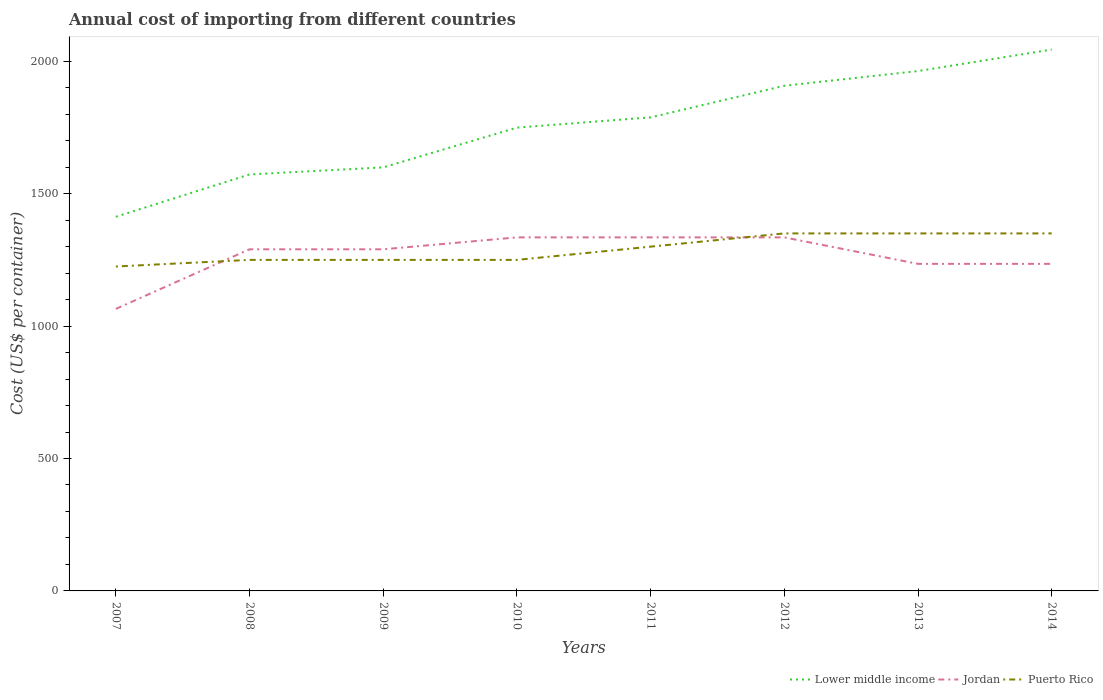How many different coloured lines are there?
Your answer should be compact. 3. Is the number of lines equal to the number of legend labels?
Your answer should be very brief. Yes. Across all years, what is the maximum total annual cost of importing in Jordan?
Offer a very short reply. 1065. In which year was the total annual cost of importing in Lower middle income maximum?
Your answer should be compact. 2007. What is the total total annual cost of importing in Jordan in the graph?
Make the answer very short. -170. What is the difference between the highest and the second highest total annual cost of importing in Jordan?
Provide a succinct answer. 270. Is the total annual cost of importing in Puerto Rico strictly greater than the total annual cost of importing in Jordan over the years?
Keep it short and to the point. No. How many lines are there?
Provide a short and direct response. 3. How many years are there in the graph?
Make the answer very short. 8. What is the difference between two consecutive major ticks on the Y-axis?
Give a very brief answer. 500. Are the values on the major ticks of Y-axis written in scientific E-notation?
Offer a very short reply. No. Does the graph contain any zero values?
Offer a very short reply. No. Does the graph contain grids?
Make the answer very short. No. Where does the legend appear in the graph?
Offer a terse response. Bottom right. What is the title of the graph?
Keep it short and to the point. Annual cost of importing from different countries. Does "Belize" appear as one of the legend labels in the graph?
Offer a terse response. No. What is the label or title of the Y-axis?
Provide a succinct answer. Cost (US$ per container). What is the Cost (US$ per container) in Lower middle income in 2007?
Offer a terse response. 1412.82. What is the Cost (US$ per container) in Jordan in 2007?
Give a very brief answer. 1065. What is the Cost (US$ per container) of Puerto Rico in 2007?
Keep it short and to the point. 1225. What is the Cost (US$ per container) in Lower middle income in 2008?
Give a very brief answer. 1572.65. What is the Cost (US$ per container) of Jordan in 2008?
Offer a terse response. 1290. What is the Cost (US$ per container) of Puerto Rico in 2008?
Your response must be concise. 1250. What is the Cost (US$ per container) in Lower middle income in 2009?
Ensure brevity in your answer.  1599.32. What is the Cost (US$ per container) of Jordan in 2009?
Ensure brevity in your answer.  1290. What is the Cost (US$ per container) in Puerto Rico in 2009?
Offer a very short reply. 1250. What is the Cost (US$ per container) of Lower middle income in 2010?
Offer a very short reply. 1749.42. What is the Cost (US$ per container) in Jordan in 2010?
Your answer should be very brief. 1335. What is the Cost (US$ per container) of Puerto Rico in 2010?
Keep it short and to the point. 1250. What is the Cost (US$ per container) of Lower middle income in 2011?
Your response must be concise. 1788.26. What is the Cost (US$ per container) of Jordan in 2011?
Offer a very short reply. 1335. What is the Cost (US$ per container) of Puerto Rico in 2011?
Provide a succinct answer. 1300. What is the Cost (US$ per container) in Lower middle income in 2012?
Your answer should be very brief. 1907.47. What is the Cost (US$ per container) of Jordan in 2012?
Provide a succinct answer. 1335. What is the Cost (US$ per container) of Puerto Rico in 2012?
Make the answer very short. 1350. What is the Cost (US$ per container) of Lower middle income in 2013?
Your response must be concise. 1963.03. What is the Cost (US$ per container) of Jordan in 2013?
Your answer should be very brief. 1235. What is the Cost (US$ per container) in Puerto Rico in 2013?
Offer a terse response. 1350. What is the Cost (US$ per container) of Lower middle income in 2014?
Provide a short and direct response. 2044.26. What is the Cost (US$ per container) of Jordan in 2014?
Ensure brevity in your answer.  1235. What is the Cost (US$ per container) in Puerto Rico in 2014?
Keep it short and to the point. 1350. Across all years, what is the maximum Cost (US$ per container) of Lower middle income?
Offer a terse response. 2044.26. Across all years, what is the maximum Cost (US$ per container) in Jordan?
Make the answer very short. 1335. Across all years, what is the maximum Cost (US$ per container) in Puerto Rico?
Keep it short and to the point. 1350. Across all years, what is the minimum Cost (US$ per container) of Lower middle income?
Give a very brief answer. 1412.82. Across all years, what is the minimum Cost (US$ per container) in Jordan?
Offer a very short reply. 1065. Across all years, what is the minimum Cost (US$ per container) of Puerto Rico?
Offer a very short reply. 1225. What is the total Cost (US$ per container) in Lower middle income in the graph?
Make the answer very short. 1.40e+04. What is the total Cost (US$ per container) of Jordan in the graph?
Offer a terse response. 1.01e+04. What is the total Cost (US$ per container) of Puerto Rico in the graph?
Provide a succinct answer. 1.03e+04. What is the difference between the Cost (US$ per container) in Lower middle income in 2007 and that in 2008?
Provide a succinct answer. -159.84. What is the difference between the Cost (US$ per container) of Jordan in 2007 and that in 2008?
Offer a very short reply. -225. What is the difference between the Cost (US$ per container) of Puerto Rico in 2007 and that in 2008?
Your answer should be very brief. -25. What is the difference between the Cost (US$ per container) of Lower middle income in 2007 and that in 2009?
Ensure brevity in your answer.  -186.5. What is the difference between the Cost (US$ per container) of Jordan in 2007 and that in 2009?
Provide a short and direct response. -225. What is the difference between the Cost (US$ per container) of Lower middle income in 2007 and that in 2010?
Make the answer very short. -336.6. What is the difference between the Cost (US$ per container) of Jordan in 2007 and that in 2010?
Offer a very short reply. -270. What is the difference between the Cost (US$ per container) of Puerto Rico in 2007 and that in 2010?
Your answer should be very brief. -25. What is the difference between the Cost (US$ per container) of Lower middle income in 2007 and that in 2011?
Provide a succinct answer. -375.44. What is the difference between the Cost (US$ per container) in Jordan in 2007 and that in 2011?
Keep it short and to the point. -270. What is the difference between the Cost (US$ per container) of Puerto Rico in 2007 and that in 2011?
Your response must be concise. -75. What is the difference between the Cost (US$ per container) of Lower middle income in 2007 and that in 2012?
Your answer should be very brief. -494.65. What is the difference between the Cost (US$ per container) in Jordan in 2007 and that in 2012?
Give a very brief answer. -270. What is the difference between the Cost (US$ per container) in Puerto Rico in 2007 and that in 2012?
Keep it short and to the point. -125. What is the difference between the Cost (US$ per container) in Lower middle income in 2007 and that in 2013?
Provide a succinct answer. -550.21. What is the difference between the Cost (US$ per container) of Jordan in 2007 and that in 2013?
Keep it short and to the point. -170. What is the difference between the Cost (US$ per container) in Puerto Rico in 2007 and that in 2013?
Provide a succinct answer. -125. What is the difference between the Cost (US$ per container) in Lower middle income in 2007 and that in 2014?
Provide a short and direct response. -631.44. What is the difference between the Cost (US$ per container) in Jordan in 2007 and that in 2014?
Ensure brevity in your answer.  -170. What is the difference between the Cost (US$ per container) in Puerto Rico in 2007 and that in 2014?
Make the answer very short. -125. What is the difference between the Cost (US$ per container) in Lower middle income in 2008 and that in 2009?
Ensure brevity in your answer.  -26.67. What is the difference between the Cost (US$ per container) of Jordan in 2008 and that in 2009?
Offer a very short reply. 0. What is the difference between the Cost (US$ per container) of Puerto Rico in 2008 and that in 2009?
Offer a very short reply. 0. What is the difference between the Cost (US$ per container) of Lower middle income in 2008 and that in 2010?
Provide a short and direct response. -176.77. What is the difference between the Cost (US$ per container) of Jordan in 2008 and that in 2010?
Give a very brief answer. -45. What is the difference between the Cost (US$ per container) in Puerto Rico in 2008 and that in 2010?
Keep it short and to the point. 0. What is the difference between the Cost (US$ per container) in Lower middle income in 2008 and that in 2011?
Provide a succinct answer. -215.61. What is the difference between the Cost (US$ per container) in Jordan in 2008 and that in 2011?
Offer a very short reply. -45. What is the difference between the Cost (US$ per container) in Lower middle income in 2008 and that in 2012?
Your answer should be compact. -334.82. What is the difference between the Cost (US$ per container) in Jordan in 2008 and that in 2012?
Make the answer very short. -45. What is the difference between the Cost (US$ per container) of Puerto Rico in 2008 and that in 2012?
Your answer should be compact. -100. What is the difference between the Cost (US$ per container) of Lower middle income in 2008 and that in 2013?
Your answer should be very brief. -390.37. What is the difference between the Cost (US$ per container) of Puerto Rico in 2008 and that in 2013?
Give a very brief answer. -100. What is the difference between the Cost (US$ per container) of Lower middle income in 2008 and that in 2014?
Provide a short and direct response. -471.61. What is the difference between the Cost (US$ per container) of Jordan in 2008 and that in 2014?
Provide a short and direct response. 55. What is the difference between the Cost (US$ per container) of Puerto Rico in 2008 and that in 2014?
Ensure brevity in your answer.  -100. What is the difference between the Cost (US$ per container) in Lower middle income in 2009 and that in 2010?
Ensure brevity in your answer.  -150.1. What is the difference between the Cost (US$ per container) of Jordan in 2009 and that in 2010?
Your response must be concise. -45. What is the difference between the Cost (US$ per container) in Puerto Rico in 2009 and that in 2010?
Ensure brevity in your answer.  0. What is the difference between the Cost (US$ per container) of Lower middle income in 2009 and that in 2011?
Provide a short and direct response. -188.94. What is the difference between the Cost (US$ per container) in Jordan in 2009 and that in 2011?
Make the answer very short. -45. What is the difference between the Cost (US$ per container) of Puerto Rico in 2009 and that in 2011?
Provide a short and direct response. -50. What is the difference between the Cost (US$ per container) of Lower middle income in 2009 and that in 2012?
Provide a short and direct response. -308.15. What is the difference between the Cost (US$ per container) in Jordan in 2009 and that in 2012?
Provide a succinct answer. -45. What is the difference between the Cost (US$ per container) in Puerto Rico in 2009 and that in 2012?
Make the answer very short. -100. What is the difference between the Cost (US$ per container) of Lower middle income in 2009 and that in 2013?
Provide a short and direct response. -363.71. What is the difference between the Cost (US$ per container) in Puerto Rico in 2009 and that in 2013?
Keep it short and to the point. -100. What is the difference between the Cost (US$ per container) in Lower middle income in 2009 and that in 2014?
Your answer should be compact. -444.94. What is the difference between the Cost (US$ per container) of Puerto Rico in 2009 and that in 2014?
Your answer should be very brief. -100. What is the difference between the Cost (US$ per container) in Lower middle income in 2010 and that in 2011?
Offer a very short reply. -38.84. What is the difference between the Cost (US$ per container) in Puerto Rico in 2010 and that in 2011?
Your answer should be very brief. -50. What is the difference between the Cost (US$ per container) in Lower middle income in 2010 and that in 2012?
Provide a succinct answer. -158.05. What is the difference between the Cost (US$ per container) of Jordan in 2010 and that in 2012?
Your answer should be compact. 0. What is the difference between the Cost (US$ per container) in Puerto Rico in 2010 and that in 2012?
Keep it short and to the point. -100. What is the difference between the Cost (US$ per container) in Lower middle income in 2010 and that in 2013?
Your response must be concise. -213.61. What is the difference between the Cost (US$ per container) of Jordan in 2010 and that in 2013?
Give a very brief answer. 100. What is the difference between the Cost (US$ per container) in Puerto Rico in 2010 and that in 2013?
Offer a terse response. -100. What is the difference between the Cost (US$ per container) in Lower middle income in 2010 and that in 2014?
Your response must be concise. -294.84. What is the difference between the Cost (US$ per container) of Jordan in 2010 and that in 2014?
Offer a terse response. 100. What is the difference between the Cost (US$ per container) in Puerto Rico in 2010 and that in 2014?
Your answer should be compact. -100. What is the difference between the Cost (US$ per container) of Lower middle income in 2011 and that in 2012?
Keep it short and to the point. -119.21. What is the difference between the Cost (US$ per container) in Lower middle income in 2011 and that in 2013?
Your answer should be very brief. -174.77. What is the difference between the Cost (US$ per container) of Puerto Rico in 2011 and that in 2013?
Keep it short and to the point. -50. What is the difference between the Cost (US$ per container) in Lower middle income in 2011 and that in 2014?
Your answer should be compact. -256. What is the difference between the Cost (US$ per container) in Jordan in 2011 and that in 2014?
Keep it short and to the point. 100. What is the difference between the Cost (US$ per container) of Puerto Rico in 2011 and that in 2014?
Your response must be concise. -50. What is the difference between the Cost (US$ per container) in Lower middle income in 2012 and that in 2013?
Your answer should be compact. -55.55. What is the difference between the Cost (US$ per container) in Puerto Rico in 2012 and that in 2013?
Keep it short and to the point. 0. What is the difference between the Cost (US$ per container) in Lower middle income in 2012 and that in 2014?
Give a very brief answer. -136.79. What is the difference between the Cost (US$ per container) of Lower middle income in 2013 and that in 2014?
Offer a very short reply. -81.24. What is the difference between the Cost (US$ per container) in Puerto Rico in 2013 and that in 2014?
Your answer should be compact. 0. What is the difference between the Cost (US$ per container) of Lower middle income in 2007 and the Cost (US$ per container) of Jordan in 2008?
Your answer should be compact. 122.82. What is the difference between the Cost (US$ per container) in Lower middle income in 2007 and the Cost (US$ per container) in Puerto Rico in 2008?
Keep it short and to the point. 162.82. What is the difference between the Cost (US$ per container) of Jordan in 2007 and the Cost (US$ per container) of Puerto Rico in 2008?
Provide a succinct answer. -185. What is the difference between the Cost (US$ per container) of Lower middle income in 2007 and the Cost (US$ per container) of Jordan in 2009?
Your answer should be compact. 122.82. What is the difference between the Cost (US$ per container) in Lower middle income in 2007 and the Cost (US$ per container) in Puerto Rico in 2009?
Your response must be concise. 162.82. What is the difference between the Cost (US$ per container) in Jordan in 2007 and the Cost (US$ per container) in Puerto Rico in 2009?
Provide a succinct answer. -185. What is the difference between the Cost (US$ per container) in Lower middle income in 2007 and the Cost (US$ per container) in Jordan in 2010?
Make the answer very short. 77.82. What is the difference between the Cost (US$ per container) of Lower middle income in 2007 and the Cost (US$ per container) of Puerto Rico in 2010?
Provide a short and direct response. 162.82. What is the difference between the Cost (US$ per container) of Jordan in 2007 and the Cost (US$ per container) of Puerto Rico in 2010?
Your response must be concise. -185. What is the difference between the Cost (US$ per container) of Lower middle income in 2007 and the Cost (US$ per container) of Jordan in 2011?
Make the answer very short. 77.82. What is the difference between the Cost (US$ per container) of Lower middle income in 2007 and the Cost (US$ per container) of Puerto Rico in 2011?
Ensure brevity in your answer.  112.82. What is the difference between the Cost (US$ per container) of Jordan in 2007 and the Cost (US$ per container) of Puerto Rico in 2011?
Offer a terse response. -235. What is the difference between the Cost (US$ per container) in Lower middle income in 2007 and the Cost (US$ per container) in Jordan in 2012?
Offer a very short reply. 77.82. What is the difference between the Cost (US$ per container) in Lower middle income in 2007 and the Cost (US$ per container) in Puerto Rico in 2012?
Make the answer very short. 62.82. What is the difference between the Cost (US$ per container) of Jordan in 2007 and the Cost (US$ per container) of Puerto Rico in 2012?
Your response must be concise. -285. What is the difference between the Cost (US$ per container) of Lower middle income in 2007 and the Cost (US$ per container) of Jordan in 2013?
Offer a terse response. 177.82. What is the difference between the Cost (US$ per container) of Lower middle income in 2007 and the Cost (US$ per container) of Puerto Rico in 2013?
Offer a terse response. 62.82. What is the difference between the Cost (US$ per container) of Jordan in 2007 and the Cost (US$ per container) of Puerto Rico in 2013?
Offer a very short reply. -285. What is the difference between the Cost (US$ per container) in Lower middle income in 2007 and the Cost (US$ per container) in Jordan in 2014?
Offer a terse response. 177.82. What is the difference between the Cost (US$ per container) in Lower middle income in 2007 and the Cost (US$ per container) in Puerto Rico in 2014?
Provide a short and direct response. 62.82. What is the difference between the Cost (US$ per container) in Jordan in 2007 and the Cost (US$ per container) in Puerto Rico in 2014?
Provide a short and direct response. -285. What is the difference between the Cost (US$ per container) in Lower middle income in 2008 and the Cost (US$ per container) in Jordan in 2009?
Provide a short and direct response. 282.65. What is the difference between the Cost (US$ per container) in Lower middle income in 2008 and the Cost (US$ per container) in Puerto Rico in 2009?
Your answer should be very brief. 322.65. What is the difference between the Cost (US$ per container) in Jordan in 2008 and the Cost (US$ per container) in Puerto Rico in 2009?
Keep it short and to the point. 40. What is the difference between the Cost (US$ per container) of Lower middle income in 2008 and the Cost (US$ per container) of Jordan in 2010?
Provide a succinct answer. 237.65. What is the difference between the Cost (US$ per container) in Lower middle income in 2008 and the Cost (US$ per container) in Puerto Rico in 2010?
Provide a short and direct response. 322.65. What is the difference between the Cost (US$ per container) in Lower middle income in 2008 and the Cost (US$ per container) in Jordan in 2011?
Give a very brief answer. 237.65. What is the difference between the Cost (US$ per container) in Lower middle income in 2008 and the Cost (US$ per container) in Puerto Rico in 2011?
Keep it short and to the point. 272.65. What is the difference between the Cost (US$ per container) of Lower middle income in 2008 and the Cost (US$ per container) of Jordan in 2012?
Your response must be concise. 237.65. What is the difference between the Cost (US$ per container) of Lower middle income in 2008 and the Cost (US$ per container) of Puerto Rico in 2012?
Give a very brief answer. 222.65. What is the difference between the Cost (US$ per container) in Jordan in 2008 and the Cost (US$ per container) in Puerto Rico in 2012?
Offer a terse response. -60. What is the difference between the Cost (US$ per container) of Lower middle income in 2008 and the Cost (US$ per container) of Jordan in 2013?
Offer a terse response. 337.65. What is the difference between the Cost (US$ per container) in Lower middle income in 2008 and the Cost (US$ per container) in Puerto Rico in 2013?
Your answer should be compact. 222.65. What is the difference between the Cost (US$ per container) of Jordan in 2008 and the Cost (US$ per container) of Puerto Rico in 2013?
Provide a short and direct response. -60. What is the difference between the Cost (US$ per container) of Lower middle income in 2008 and the Cost (US$ per container) of Jordan in 2014?
Your answer should be very brief. 337.65. What is the difference between the Cost (US$ per container) of Lower middle income in 2008 and the Cost (US$ per container) of Puerto Rico in 2014?
Make the answer very short. 222.65. What is the difference between the Cost (US$ per container) in Jordan in 2008 and the Cost (US$ per container) in Puerto Rico in 2014?
Your answer should be compact. -60. What is the difference between the Cost (US$ per container) of Lower middle income in 2009 and the Cost (US$ per container) of Jordan in 2010?
Provide a short and direct response. 264.32. What is the difference between the Cost (US$ per container) of Lower middle income in 2009 and the Cost (US$ per container) of Puerto Rico in 2010?
Your answer should be compact. 349.32. What is the difference between the Cost (US$ per container) in Jordan in 2009 and the Cost (US$ per container) in Puerto Rico in 2010?
Offer a terse response. 40. What is the difference between the Cost (US$ per container) of Lower middle income in 2009 and the Cost (US$ per container) of Jordan in 2011?
Offer a very short reply. 264.32. What is the difference between the Cost (US$ per container) in Lower middle income in 2009 and the Cost (US$ per container) in Puerto Rico in 2011?
Your answer should be very brief. 299.32. What is the difference between the Cost (US$ per container) of Jordan in 2009 and the Cost (US$ per container) of Puerto Rico in 2011?
Ensure brevity in your answer.  -10. What is the difference between the Cost (US$ per container) of Lower middle income in 2009 and the Cost (US$ per container) of Jordan in 2012?
Make the answer very short. 264.32. What is the difference between the Cost (US$ per container) in Lower middle income in 2009 and the Cost (US$ per container) in Puerto Rico in 2012?
Your response must be concise. 249.32. What is the difference between the Cost (US$ per container) of Jordan in 2009 and the Cost (US$ per container) of Puerto Rico in 2012?
Offer a very short reply. -60. What is the difference between the Cost (US$ per container) in Lower middle income in 2009 and the Cost (US$ per container) in Jordan in 2013?
Give a very brief answer. 364.32. What is the difference between the Cost (US$ per container) in Lower middle income in 2009 and the Cost (US$ per container) in Puerto Rico in 2013?
Offer a terse response. 249.32. What is the difference between the Cost (US$ per container) of Jordan in 2009 and the Cost (US$ per container) of Puerto Rico in 2013?
Make the answer very short. -60. What is the difference between the Cost (US$ per container) of Lower middle income in 2009 and the Cost (US$ per container) of Jordan in 2014?
Give a very brief answer. 364.32. What is the difference between the Cost (US$ per container) of Lower middle income in 2009 and the Cost (US$ per container) of Puerto Rico in 2014?
Provide a succinct answer. 249.32. What is the difference between the Cost (US$ per container) in Jordan in 2009 and the Cost (US$ per container) in Puerto Rico in 2014?
Give a very brief answer. -60. What is the difference between the Cost (US$ per container) in Lower middle income in 2010 and the Cost (US$ per container) in Jordan in 2011?
Ensure brevity in your answer.  414.42. What is the difference between the Cost (US$ per container) of Lower middle income in 2010 and the Cost (US$ per container) of Puerto Rico in 2011?
Your response must be concise. 449.42. What is the difference between the Cost (US$ per container) in Lower middle income in 2010 and the Cost (US$ per container) in Jordan in 2012?
Ensure brevity in your answer.  414.42. What is the difference between the Cost (US$ per container) in Lower middle income in 2010 and the Cost (US$ per container) in Puerto Rico in 2012?
Make the answer very short. 399.42. What is the difference between the Cost (US$ per container) in Lower middle income in 2010 and the Cost (US$ per container) in Jordan in 2013?
Offer a very short reply. 514.42. What is the difference between the Cost (US$ per container) of Lower middle income in 2010 and the Cost (US$ per container) of Puerto Rico in 2013?
Ensure brevity in your answer.  399.42. What is the difference between the Cost (US$ per container) in Jordan in 2010 and the Cost (US$ per container) in Puerto Rico in 2013?
Keep it short and to the point. -15. What is the difference between the Cost (US$ per container) of Lower middle income in 2010 and the Cost (US$ per container) of Jordan in 2014?
Your answer should be compact. 514.42. What is the difference between the Cost (US$ per container) of Lower middle income in 2010 and the Cost (US$ per container) of Puerto Rico in 2014?
Make the answer very short. 399.42. What is the difference between the Cost (US$ per container) of Jordan in 2010 and the Cost (US$ per container) of Puerto Rico in 2014?
Your answer should be very brief. -15. What is the difference between the Cost (US$ per container) in Lower middle income in 2011 and the Cost (US$ per container) in Jordan in 2012?
Ensure brevity in your answer.  453.26. What is the difference between the Cost (US$ per container) of Lower middle income in 2011 and the Cost (US$ per container) of Puerto Rico in 2012?
Make the answer very short. 438.26. What is the difference between the Cost (US$ per container) of Lower middle income in 2011 and the Cost (US$ per container) of Jordan in 2013?
Ensure brevity in your answer.  553.26. What is the difference between the Cost (US$ per container) of Lower middle income in 2011 and the Cost (US$ per container) of Puerto Rico in 2013?
Give a very brief answer. 438.26. What is the difference between the Cost (US$ per container) of Lower middle income in 2011 and the Cost (US$ per container) of Jordan in 2014?
Your answer should be compact. 553.26. What is the difference between the Cost (US$ per container) in Lower middle income in 2011 and the Cost (US$ per container) in Puerto Rico in 2014?
Offer a very short reply. 438.26. What is the difference between the Cost (US$ per container) of Lower middle income in 2012 and the Cost (US$ per container) of Jordan in 2013?
Your answer should be very brief. 672.47. What is the difference between the Cost (US$ per container) in Lower middle income in 2012 and the Cost (US$ per container) in Puerto Rico in 2013?
Offer a very short reply. 557.47. What is the difference between the Cost (US$ per container) of Jordan in 2012 and the Cost (US$ per container) of Puerto Rico in 2013?
Offer a terse response. -15. What is the difference between the Cost (US$ per container) of Lower middle income in 2012 and the Cost (US$ per container) of Jordan in 2014?
Keep it short and to the point. 672.47. What is the difference between the Cost (US$ per container) of Lower middle income in 2012 and the Cost (US$ per container) of Puerto Rico in 2014?
Your response must be concise. 557.47. What is the difference between the Cost (US$ per container) of Jordan in 2012 and the Cost (US$ per container) of Puerto Rico in 2014?
Your answer should be very brief. -15. What is the difference between the Cost (US$ per container) in Lower middle income in 2013 and the Cost (US$ per container) in Jordan in 2014?
Offer a very short reply. 728.03. What is the difference between the Cost (US$ per container) of Lower middle income in 2013 and the Cost (US$ per container) of Puerto Rico in 2014?
Ensure brevity in your answer.  613.03. What is the difference between the Cost (US$ per container) of Jordan in 2013 and the Cost (US$ per container) of Puerto Rico in 2014?
Your answer should be compact. -115. What is the average Cost (US$ per container) in Lower middle income per year?
Give a very brief answer. 1754.65. What is the average Cost (US$ per container) of Jordan per year?
Give a very brief answer. 1265. What is the average Cost (US$ per container) of Puerto Rico per year?
Offer a terse response. 1290.62. In the year 2007, what is the difference between the Cost (US$ per container) in Lower middle income and Cost (US$ per container) in Jordan?
Your response must be concise. 347.82. In the year 2007, what is the difference between the Cost (US$ per container) of Lower middle income and Cost (US$ per container) of Puerto Rico?
Offer a terse response. 187.82. In the year 2007, what is the difference between the Cost (US$ per container) of Jordan and Cost (US$ per container) of Puerto Rico?
Your answer should be compact. -160. In the year 2008, what is the difference between the Cost (US$ per container) in Lower middle income and Cost (US$ per container) in Jordan?
Your answer should be compact. 282.65. In the year 2008, what is the difference between the Cost (US$ per container) of Lower middle income and Cost (US$ per container) of Puerto Rico?
Your response must be concise. 322.65. In the year 2008, what is the difference between the Cost (US$ per container) in Jordan and Cost (US$ per container) in Puerto Rico?
Make the answer very short. 40. In the year 2009, what is the difference between the Cost (US$ per container) in Lower middle income and Cost (US$ per container) in Jordan?
Ensure brevity in your answer.  309.32. In the year 2009, what is the difference between the Cost (US$ per container) of Lower middle income and Cost (US$ per container) of Puerto Rico?
Offer a very short reply. 349.32. In the year 2009, what is the difference between the Cost (US$ per container) in Jordan and Cost (US$ per container) in Puerto Rico?
Provide a short and direct response. 40. In the year 2010, what is the difference between the Cost (US$ per container) of Lower middle income and Cost (US$ per container) of Jordan?
Keep it short and to the point. 414.42. In the year 2010, what is the difference between the Cost (US$ per container) of Lower middle income and Cost (US$ per container) of Puerto Rico?
Ensure brevity in your answer.  499.42. In the year 2010, what is the difference between the Cost (US$ per container) of Jordan and Cost (US$ per container) of Puerto Rico?
Your answer should be very brief. 85. In the year 2011, what is the difference between the Cost (US$ per container) in Lower middle income and Cost (US$ per container) in Jordan?
Your answer should be very brief. 453.26. In the year 2011, what is the difference between the Cost (US$ per container) of Lower middle income and Cost (US$ per container) of Puerto Rico?
Make the answer very short. 488.26. In the year 2011, what is the difference between the Cost (US$ per container) in Jordan and Cost (US$ per container) in Puerto Rico?
Ensure brevity in your answer.  35. In the year 2012, what is the difference between the Cost (US$ per container) of Lower middle income and Cost (US$ per container) of Jordan?
Ensure brevity in your answer.  572.47. In the year 2012, what is the difference between the Cost (US$ per container) in Lower middle income and Cost (US$ per container) in Puerto Rico?
Keep it short and to the point. 557.47. In the year 2013, what is the difference between the Cost (US$ per container) of Lower middle income and Cost (US$ per container) of Jordan?
Make the answer very short. 728.03. In the year 2013, what is the difference between the Cost (US$ per container) in Lower middle income and Cost (US$ per container) in Puerto Rico?
Keep it short and to the point. 613.03. In the year 2013, what is the difference between the Cost (US$ per container) in Jordan and Cost (US$ per container) in Puerto Rico?
Offer a terse response. -115. In the year 2014, what is the difference between the Cost (US$ per container) of Lower middle income and Cost (US$ per container) of Jordan?
Offer a terse response. 809.26. In the year 2014, what is the difference between the Cost (US$ per container) in Lower middle income and Cost (US$ per container) in Puerto Rico?
Offer a terse response. 694.26. In the year 2014, what is the difference between the Cost (US$ per container) of Jordan and Cost (US$ per container) of Puerto Rico?
Offer a terse response. -115. What is the ratio of the Cost (US$ per container) in Lower middle income in 2007 to that in 2008?
Provide a succinct answer. 0.9. What is the ratio of the Cost (US$ per container) of Jordan in 2007 to that in 2008?
Your answer should be very brief. 0.83. What is the ratio of the Cost (US$ per container) of Lower middle income in 2007 to that in 2009?
Provide a succinct answer. 0.88. What is the ratio of the Cost (US$ per container) of Jordan in 2007 to that in 2009?
Offer a very short reply. 0.83. What is the ratio of the Cost (US$ per container) in Puerto Rico in 2007 to that in 2009?
Provide a succinct answer. 0.98. What is the ratio of the Cost (US$ per container) in Lower middle income in 2007 to that in 2010?
Offer a very short reply. 0.81. What is the ratio of the Cost (US$ per container) of Jordan in 2007 to that in 2010?
Offer a terse response. 0.8. What is the ratio of the Cost (US$ per container) in Lower middle income in 2007 to that in 2011?
Ensure brevity in your answer.  0.79. What is the ratio of the Cost (US$ per container) of Jordan in 2007 to that in 2011?
Your answer should be very brief. 0.8. What is the ratio of the Cost (US$ per container) of Puerto Rico in 2007 to that in 2011?
Offer a terse response. 0.94. What is the ratio of the Cost (US$ per container) in Lower middle income in 2007 to that in 2012?
Give a very brief answer. 0.74. What is the ratio of the Cost (US$ per container) of Jordan in 2007 to that in 2012?
Provide a short and direct response. 0.8. What is the ratio of the Cost (US$ per container) in Puerto Rico in 2007 to that in 2012?
Keep it short and to the point. 0.91. What is the ratio of the Cost (US$ per container) in Lower middle income in 2007 to that in 2013?
Your answer should be very brief. 0.72. What is the ratio of the Cost (US$ per container) in Jordan in 2007 to that in 2013?
Keep it short and to the point. 0.86. What is the ratio of the Cost (US$ per container) in Puerto Rico in 2007 to that in 2013?
Provide a succinct answer. 0.91. What is the ratio of the Cost (US$ per container) in Lower middle income in 2007 to that in 2014?
Keep it short and to the point. 0.69. What is the ratio of the Cost (US$ per container) of Jordan in 2007 to that in 2014?
Keep it short and to the point. 0.86. What is the ratio of the Cost (US$ per container) of Puerto Rico in 2007 to that in 2014?
Make the answer very short. 0.91. What is the ratio of the Cost (US$ per container) in Lower middle income in 2008 to that in 2009?
Provide a short and direct response. 0.98. What is the ratio of the Cost (US$ per container) of Jordan in 2008 to that in 2009?
Offer a terse response. 1. What is the ratio of the Cost (US$ per container) in Puerto Rico in 2008 to that in 2009?
Keep it short and to the point. 1. What is the ratio of the Cost (US$ per container) in Lower middle income in 2008 to that in 2010?
Offer a terse response. 0.9. What is the ratio of the Cost (US$ per container) in Jordan in 2008 to that in 2010?
Keep it short and to the point. 0.97. What is the ratio of the Cost (US$ per container) in Puerto Rico in 2008 to that in 2010?
Give a very brief answer. 1. What is the ratio of the Cost (US$ per container) of Lower middle income in 2008 to that in 2011?
Provide a short and direct response. 0.88. What is the ratio of the Cost (US$ per container) in Jordan in 2008 to that in 2011?
Offer a very short reply. 0.97. What is the ratio of the Cost (US$ per container) of Puerto Rico in 2008 to that in 2011?
Provide a succinct answer. 0.96. What is the ratio of the Cost (US$ per container) of Lower middle income in 2008 to that in 2012?
Offer a very short reply. 0.82. What is the ratio of the Cost (US$ per container) in Jordan in 2008 to that in 2012?
Provide a short and direct response. 0.97. What is the ratio of the Cost (US$ per container) in Puerto Rico in 2008 to that in 2012?
Your answer should be very brief. 0.93. What is the ratio of the Cost (US$ per container) in Lower middle income in 2008 to that in 2013?
Make the answer very short. 0.8. What is the ratio of the Cost (US$ per container) of Jordan in 2008 to that in 2013?
Your answer should be compact. 1.04. What is the ratio of the Cost (US$ per container) in Puerto Rico in 2008 to that in 2013?
Make the answer very short. 0.93. What is the ratio of the Cost (US$ per container) in Lower middle income in 2008 to that in 2014?
Offer a very short reply. 0.77. What is the ratio of the Cost (US$ per container) in Jordan in 2008 to that in 2014?
Make the answer very short. 1.04. What is the ratio of the Cost (US$ per container) of Puerto Rico in 2008 to that in 2014?
Offer a very short reply. 0.93. What is the ratio of the Cost (US$ per container) in Lower middle income in 2009 to that in 2010?
Keep it short and to the point. 0.91. What is the ratio of the Cost (US$ per container) of Jordan in 2009 to that in 2010?
Ensure brevity in your answer.  0.97. What is the ratio of the Cost (US$ per container) in Lower middle income in 2009 to that in 2011?
Provide a short and direct response. 0.89. What is the ratio of the Cost (US$ per container) of Jordan in 2009 to that in 2011?
Your response must be concise. 0.97. What is the ratio of the Cost (US$ per container) of Puerto Rico in 2009 to that in 2011?
Your answer should be compact. 0.96. What is the ratio of the Cost (US$ per container) of Lower middle income in 2009 to that in 2012?
Offer a terse response. 0.84. What is the ratio of the Cost (US$ per container) of Jordan in 2009 to that in 2012?
Keep it short and to the point. 0.97. What is the ratio of the Cost (US$ per container) of Puerto Rico in 2009 to that in 2012?
Offer a very short reply. 0.93. What is the ratio of the Cost (US$ per container) of Lower middle income in 2009 to that in 2013?
Make the answer very short. 0.81. What is the ratio of the Cost (US$ per container) of Jordan in 2009 to that in 2013?
Ensure brevity in your answer.  1.04. What is the ratio of the Cost (US$ per container) of Puerto Rico in 2009 to that in 2013?
Make the answer very short. 0.93. What is the ratio of the Cost (US$ per container) of Lower middle income in 2009 to that in 2014?
Offer a terse response. 0.78. What is the ratio of the Cost (US$ per container) in Jordan in 2009 to that in 2014?
Offer a very short reply. 1.04. What is the ratio of the Cost (US$ per container) in Puerto Rico in 2009 to that in 2014?
Keep it short and to the point. 0.93. What is the ratio of the Cost (US$ per container) in Lower middle income in 2010 to that in 2011?
Give a very brief answer. 0.98. What is the ratio of the Cost (US$ per container) of Jordan in 2010 to that in 2011?
Make the answer very short. 1. What is the ratio of the Cost (US$ per container) of Puerto Rico in 2010 to that in 2011?
Offer a very short reply. 0.96. What is the ratio of the Cost (US$ per container) in Lower middle income in 2010 to that in 2012?
Offer a terse response. 0.92. What is the ratio of the Cost (US$ per container) in Puerto Rico in 2010 to that in 2012?
Your answer should be very brief. 0.93. What is the ratio of the Cost (US$ per container) of Lower middle income in 2010 to that in 2013?
Provide a succinct answer. 0.89. What is the ratio of the Cost (US$ per container) in Jordan in 2010 to that in 2013?
Ensure brevity in your answer.  1.08. What is the ratio of the Cost (US$ per container) in Puerto Rico in 2010 to that in 2013?
Offer a very short reply. 0.93. What is the ratio of the Cost (US$ per container) of Lower middle income in 2010 to that in 2014?
Give a very brief answer. 0.86. What is the ratio of the Cost (US$ per container) of Jordan in 2010 to that in 2014?
Offer a very short reply. 1.08. What is the ratio of the Cost (US$ per container) of Puerto Rico in 2010 to that in 2014?
Give a very brief answer. 0.93. What is the ratio of the Cost (US$ per container) of Jordan in 2011 to that in 2012?
Your answer should be compact. 1. What is the ratio of the Cost (US$ per container) of Puerto Rico in 2011 to that in 2012?
Your answer should be compact. 0.96. What is the ratio of the Cost (US$ per container) in Lower middle income in 2011 to that in 2013?
Give a very brief answer. 0.91. What is the ratio of the Cost (US$ per container) of Jordan in 2011 to that in 2013?
Offer a very short reply. 1.08. What is the ratio of the Cost (US$ per container) in Puerto Rico in 2011 to that in 2013?
Your answer should be very brief. 0.96. What is the ratio of the Cost (US$ per container) of Lower middle income in 2011 to that in 2014?
Make the answer very short. 0.87. What is the ratio of the Cost (US$ per container) in Jordan in 2011 to that in 2014?
Ensure brevity in your answer.  1.08. What is the ratio of the Cost (US$ per container) of Lower middle income in 2012 to that in 2013?
Provide a short and direct response. 0.97. What is the ratio of the Cost (US$ per container) in Jordan in 2012 to that in 2013?
Your answer should be very brief. 1.08. What is the ratio of the Cost (US$ per container) of Lower middle income in 2012 to that in 2014?
Ensure brevity in your answer.  0.93. What is the ratio of the Cost (US$ per container) in Jordan in 2012 to that in 2014?
Keep it short and to the point. 1.08. What is the ratio of the Cost (US$ per container) of Puerto Rico in 2012 to that in 2014?
Make the answer very short. 1. What is the ratio of the Cost (US$ per container) in Lower middle income in 2013 to that in 2014?
Offer a terse response. 0.96. What is the ratio of the Cost (US$ per container) in Puerto Rico in 2013 to that in 2014?
Provide a short and direct response. 1. What is the difference between the highest and the second highest Cost (US$ per container) in Lower middle income?
Offer a terse response. 81.24. What is the difference between the highest and the second highest Cost (US$ per container) in Jordan?
Give a very brief answer. 0. What is the difference between the highest and the second highest Cost (US$ per container) of Puerto Rico?
Your answer should be very brief. 0. What is the difference between the highest and the lowest Cost (US$ per container) of Lower middle income?
Provide a succinct answer. 631.44. What is the difference between the highest and the lowest Cost (US$ per container) of Jordan?
Make the answer very short. 270. What is the difference between the highest and the lowest Cost (US$ per container) in Puerto Rico?
Ensure brevity in your answer.  125. 